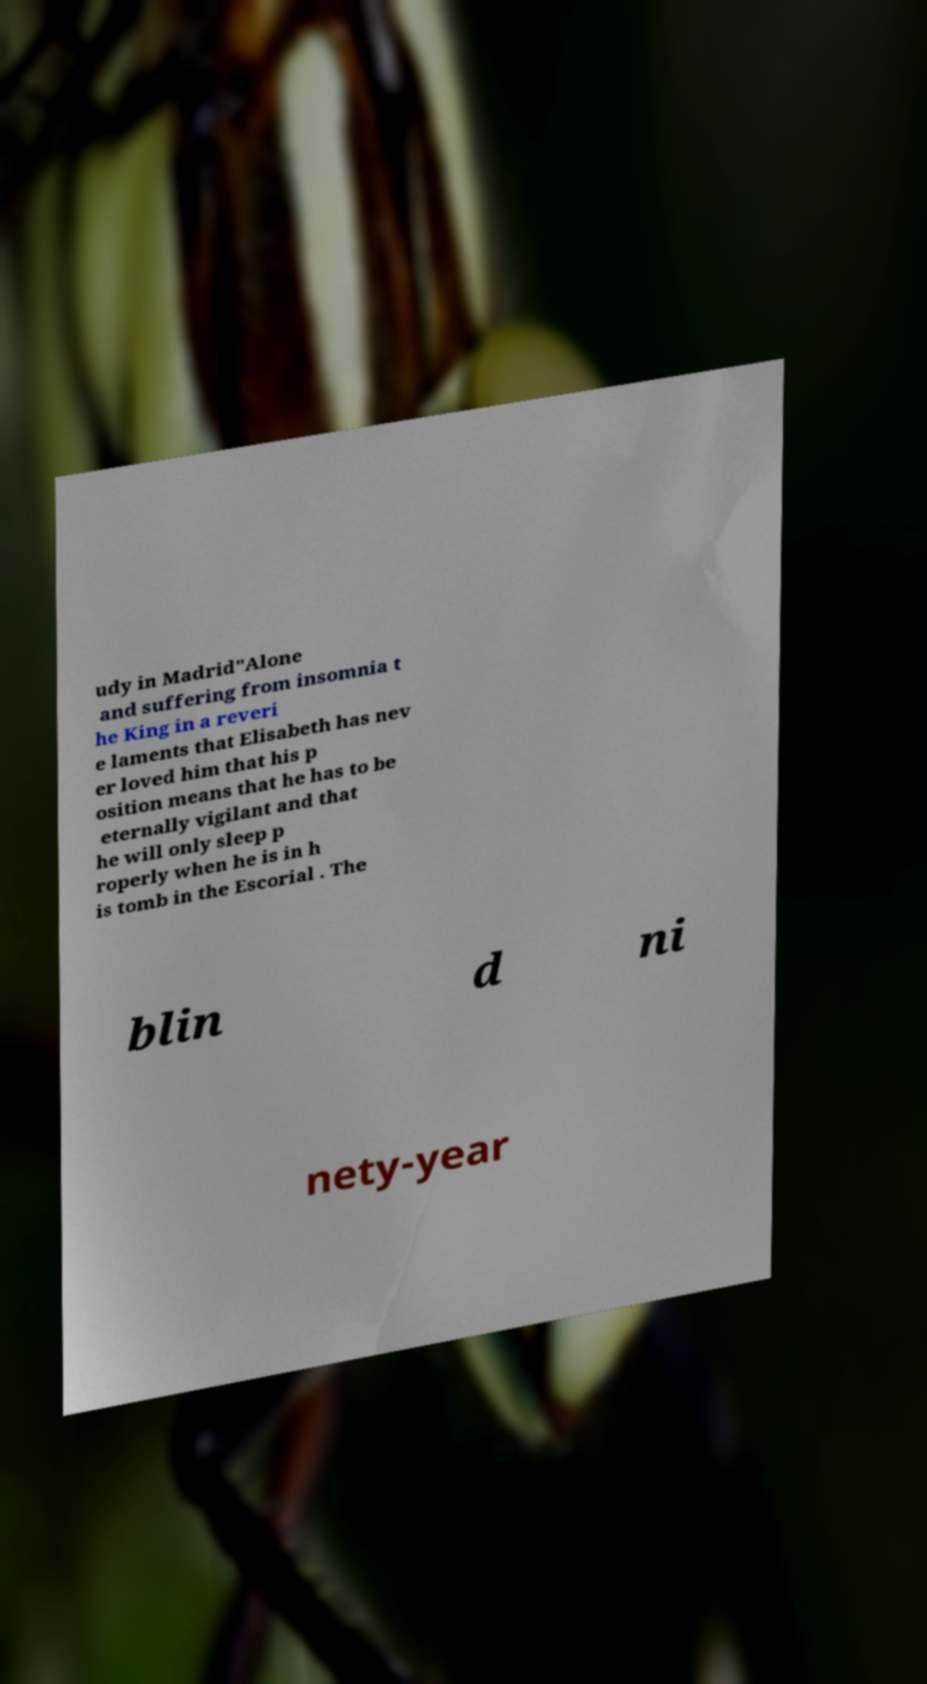Could you extract and type out the text from this image? udy in Madrid"Alone and suffering from insomnia t he King in a reveri e laments that Elisabeth has nev er loved him that his p osition means that he has to be eternally vigilant and that he will only sleep p roperly when he is in h is tomb in the Escorial . The blin d ni nety-year 